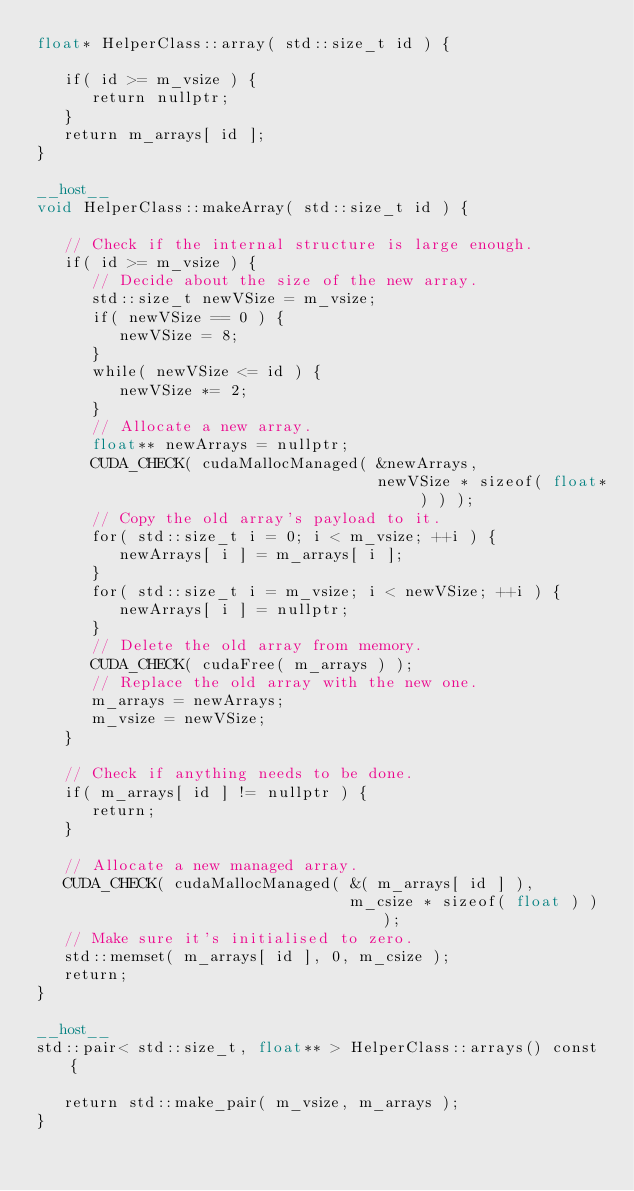Convert code to text. <code><loc_0><loc_0><loc_500><loc_500><_Cuda_>float* HelperClass::array( std::size_t id ) {

   if( id >= m_vsize ) {
      return nullptr;
   }
   return m_arrays[ id ];
}

__host__
void HelperClass::makeArray( std::size_t id ) {

   // Check if the internal structure is large enough.
   if( id >= m_vsize ) {
      // Decide about the size of the new array.
      std::size_t newVSize = m_vsize;
      if( newVSize == 0 ) {
         newVSize = 8;
      }
      while( newVSize <= id ) {
         newVSize *= 2;
      }
      // Allocate a new array.
      float** newArrays = nullptr;
      CUDA_CHECK( cudaMallocManaged( &newArrays,
                                     newVSize * sizeof( float* ) ) );
      // Copy the old array's payload to it.
      for( std::size_t i = 0; i < m_vsize; ++i ) {
         newArrays[ i ] = m_arrays[ i ];
      }
      for( std::size_t i = m_vsize; i < newVSize; ++i ) {
         newArrays[ i ] = nullptr;
      }
      // Delete the old array from memory.
      CUDA_CHECK( cudaFree( m_arrays ) );
      // Replace the old array with the new one.
      m_arrays = newArrays;
      m_vsize = newVSize;
   }

   // Check if anything needs to be done.
   if( m_arrays[ id ] != nullptr ) {
      return;
   }

   // Allocate a new managed array.
   CUDA_CHECK( cudaMallocManaged( &( m_arrays[ id ] ),
                                  m_csize * sizeof( float ) ) );
   // Make sure it's initialised to zero.
   std::memset( m_arrays[ id ], 0, m_csize );
   return;
}

__host__
std::pair< std::size_t, float** > HelperClass::arrays() const {

   return std::make_pair( m_vsize, m_arrays );
}
</code> 